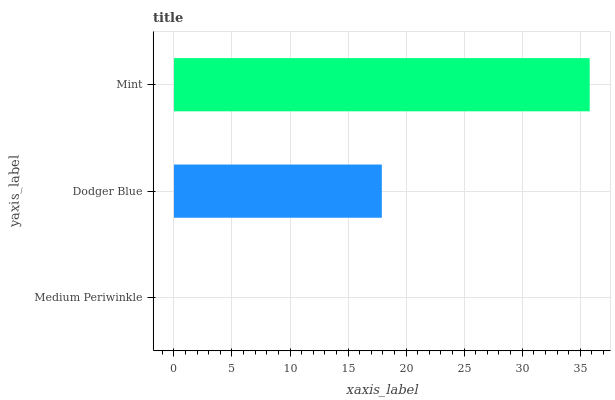Is Medium Periwinkle the minimum?
Answer yes or no. Yes. Is Mint the maximum?
Answer yes or no. Yes. Is Dodger Blue the minimum?
Answer yes or no. No. Is Dodger Blue the maximum?
Answer yes or no. No. Is Dodger Blue greater than Medium Periwinkle?
Answer yes or no. Yes. Is Medium Periwinkle less than Dodger Blue?
Answer yes or no. Yes. Is Medium Periwinkle greater than Dodger Blue?
Answer yes or no. No. Is Dodger Blue less than Medium Periwinkle?
Answer yes or no. No. Is Dodger Blue the high median?
Answer yes or no. Yes. Is Dodger Blue the low median?
Answer yes or no. Yes. Is Mint the high median?
Answer yes or no. No. Is Medium Periwinkle the low median?
Answer yes or no. No. 